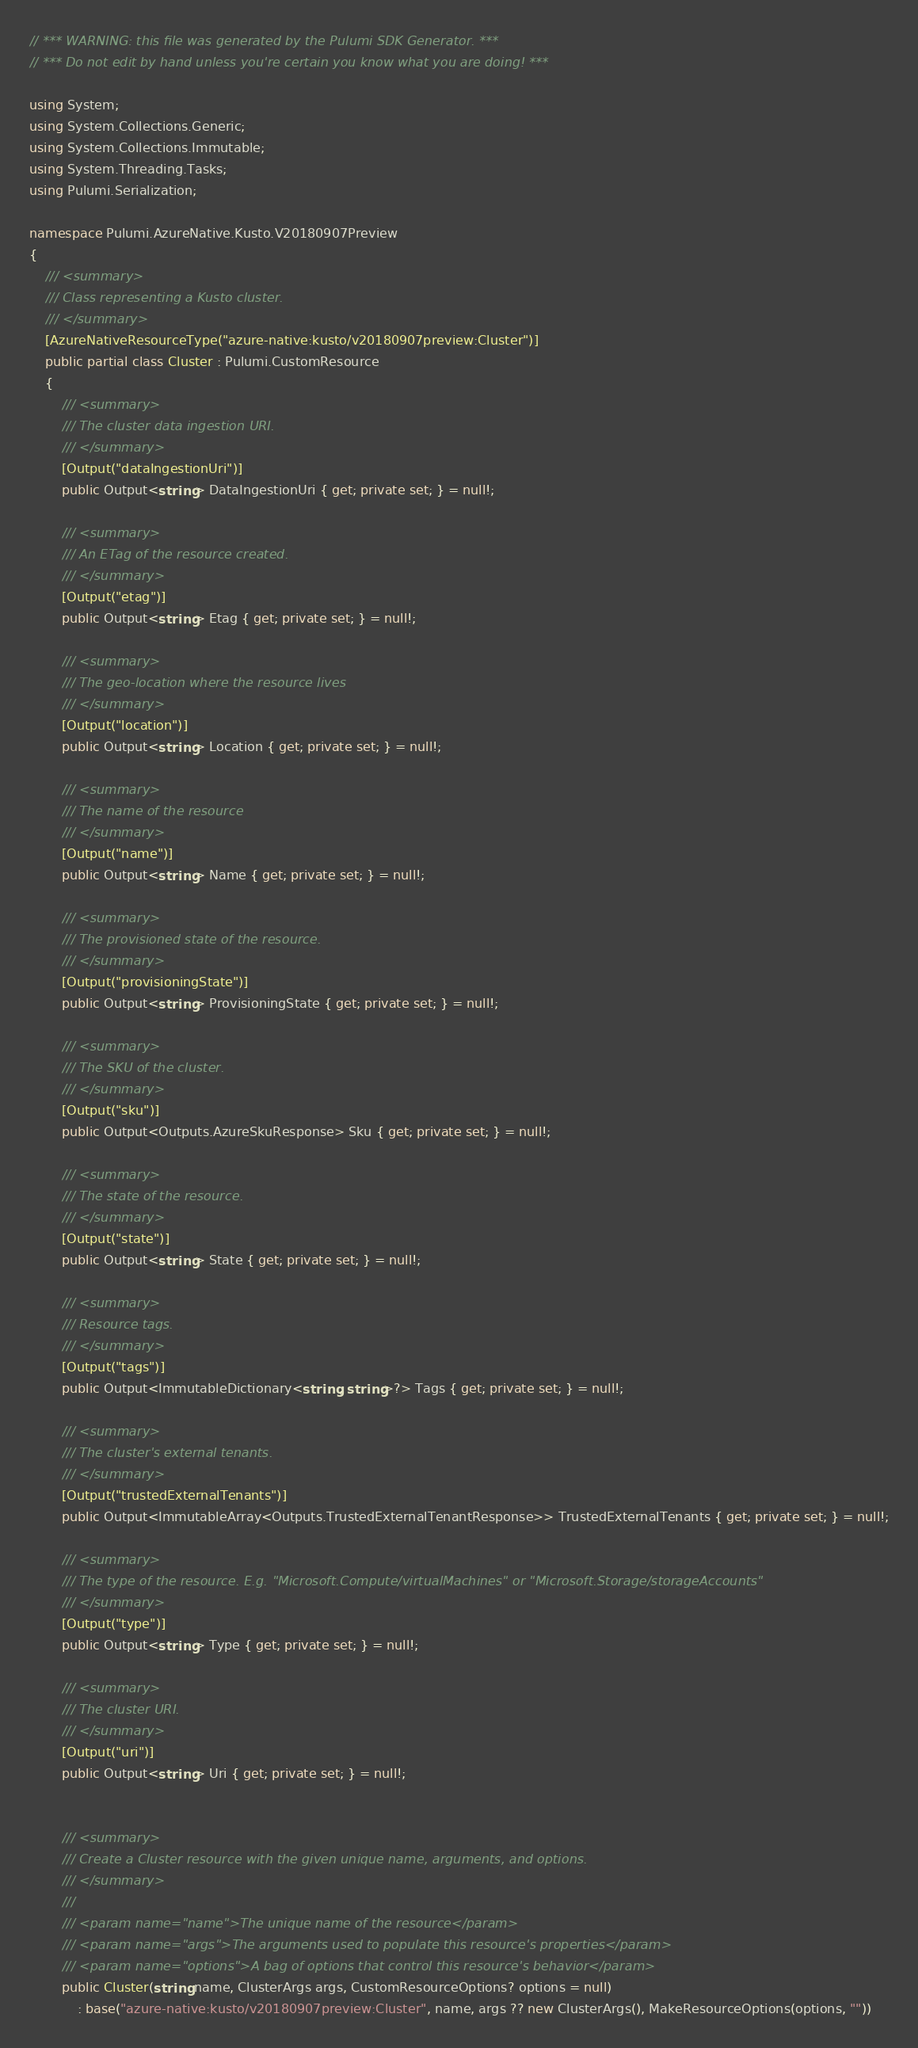<code> <loc_0><loc_0><loc_500><loc_500><_C#_>// *** WARNING: this file was generated by the Pulumi SDK Generator. ***
// *** Do not edit by hand unless you're certain you know what you are doing! ***

using System;
using System.Collections.Generic;
using System.Collections.Immutable;
using System.Threading.Tasks;
using Pulumi.Serialization;

namespace Pulumi.AzureNative.Kusto.V20180907Preview
{
    /// <summary>
    /// Class representing a Kusto cluster.
    /// </summary>
    [AzureNativeResourceType("azure-native:kusto/v20180907preview:Cluster")]
    public partial class Cluster : Pulumi.CustomResource
    {
        /// <summary>
        /// The cluster data ingestion URI.
        /// </summary>
        [Output("dataIngestionUri")]
        public Output<string> DataIngestionUri { get; private set; } = null!;

        /// <summary>
        /// An ETag of the resource created.
        /// </summary>
        [Output("etag")]
        public Output<string> Etag { get; private set; } = null!;

        /// <summary>
        /// The geo-location where the resource lives
        /// </summary>
        [Output("location")]
        public Output<string> Location { get; private set; } = null!;

        /// <summary>
        /// The name of the resource
        /// </summary>
        [Output("name")]
        public Output<string> Name { get; private set; } = null!;

        /// <summary>
        /// The provisioned state of the resource.
        /// </summary>
        [Output("provisioningState")]
        public Output<string> ProvisioningState { get; private set; } = null!;

        /// <summary>
        /// The SKU of the cluster.
        /// </summary>
        [Output("sku")]
        public Output<Outputs.AzureSkuResponse> Sku { get; private set; } = null!;

        /// <summary>
        /// The state of the resource.
        /// </summary>
        [Output("state")]
        public Output<string> State { get; private set; } = null!;

        /// <summary>
        /// Resource tags.
        /// </summary>
        [Output("tags")]
        public Output<ImmutableDictionary<string, string>?> Tags { get; private set; } = null!;

        /// <summary>
        /// The cluster's external tenants.
        /// </summary>
        [Output("trustedExternalTenants")]
        public Output<ImmutableArray<Outputs.TrustedExternalTenantResponse>> TrustedExternalTenants { get; private set; } = null!;

        /// <summary>
        /// The type of the resource. E.g. "Microsoft.Compute/virtualMachines" or "Microsoft.Storage/storageAccounts"
        /// </summary>
        [Output("type")]
        public Output<string> Type { get; private set; } = null!;

        /// <summary>
        /// The cluster URI.
        /// </summary>
        [Output("uri")]
        public Output<string> Uri { get; private set; } = null!;


        /// <summary>
        /// Create a Cluster resource with the given unique name, arguments, and options.
        /// </summary>
        ///
        /// <param name="name">The unique name of the resource</param>
        /// <param name="args">The arguments used to populate this resource's properties</param>
        /// <param name="options">A bag of options that control this resource's behavior</param>
        public Cluster(string name, ClusterArgs args, CustomResourceOptions? options = null)
            : base("azure-native:kusto/v20180907preview:Cluster", name, args ?? new ClusterArgs(), MakeResourceOptions(options, ""))</code> 